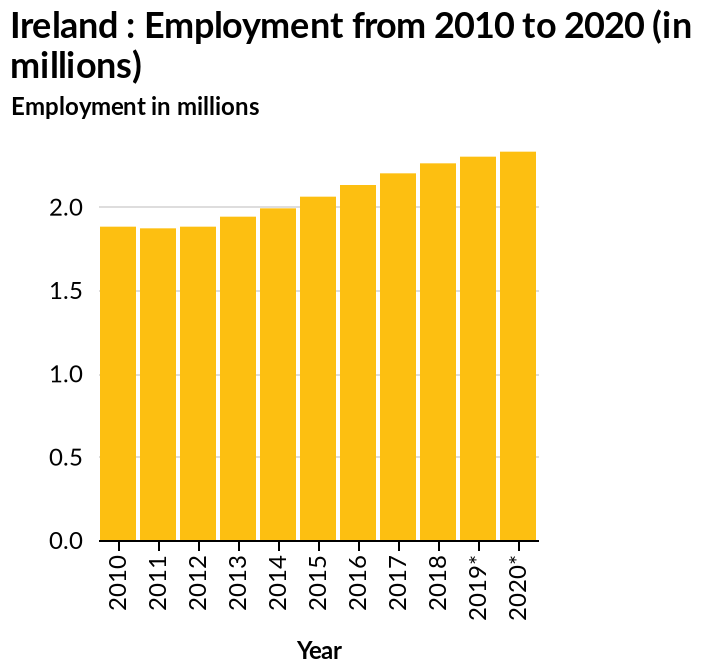<image>
please enumerates aspects of the construction of the chart Ireland : Employment from 2010 to 2020 (in millions) is a bar graph. A categorical scale starting with 2010 and ending with 2020* can be seen on the x-axis, labeled Year. Employment in millions is plotted along the y-axis. 